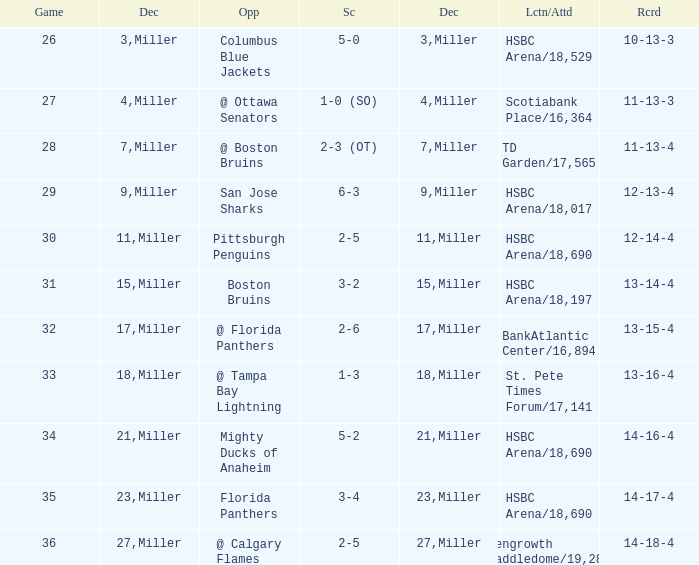Name the number of game 2-6 1.0. 